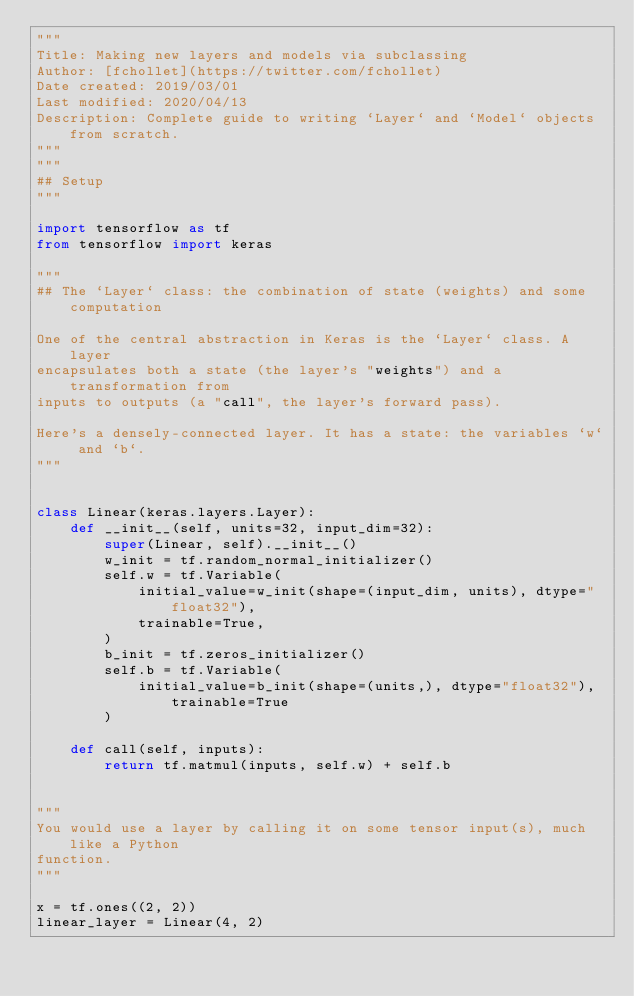<code> <loc_0><loc_0><loc_500><loc_500><_Python_>"""
Title: Making new layers and models via subclassing
Author: [fchollet](https://twitter.com/fchollet)
Date created: 2019/03/01
Last modified: 2020/04/13
Description: Complete guide to writing `Layer` and `Model` objects from scratch.
"""
"""
## Setup
"""

import tensorflow as tf
from tensorflow import keras

"""
## The `Layer` class: the combination of state (weights) and some computation

One of the central abstraction in Keras is the `Layer` class. A layer
encapsulates both a state (the layer's "weights") and a transformation from
inputs to outputs (a "call", the layer's forward pass).

Here's a densely-connected layer. It has a state: the variables `w` and `b`.
"""


class Linear(keras.layers.Layer):
    def __init__(self, units=32, input_dim=32):
        super(Linear, self).__init__()
        w_init = tf.random_normal_initializer()
        self.w = tf.Variable(
            initial_value=w_init(shape=(input_dim, units), dtype="float32"),
            trainable=True,
        )
        b_init = tf.zeros_initializer()
        self.b = tf.Variable(
            initial_value=b_init(shape=(units,), dtype="float32"), trainable=True
        )

    def call(self, inputs):
        return tf.matmul(inputs, self.w) + self.b


"""
You would use a layer by calling it on some tensor input(s), much like a Python
function.
"""

x = tf.ones((2, 2))
linear_layer = Linear(4, 2)</code> 